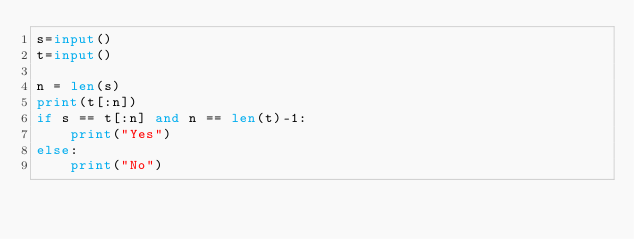<code> <loc_0><loc_0><loc_500><loc_500><_Python_>s=input()
t=input()

n = len(s)
print(t[:n])
if s == t[:n] and n == len(t)-1:
    print("Yes")
else:
    print("No")</code> 